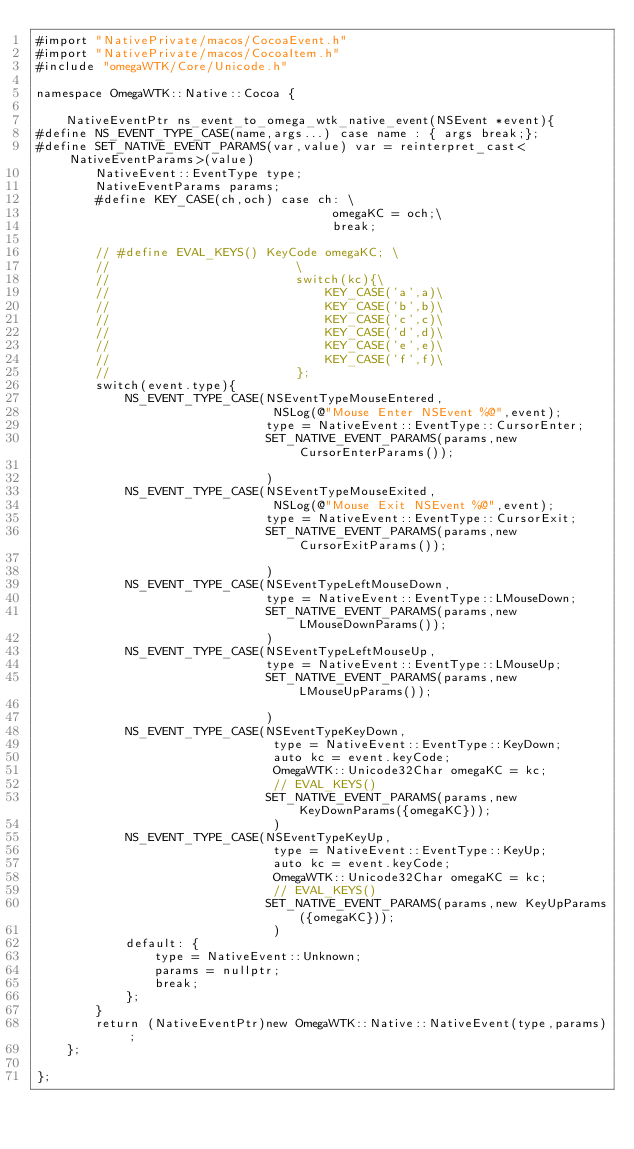Convert code to text. <code><loc_0><loc_0><loc_500><loc_500><_ObjectiveC_>#import "NativePrivate/macos/CocoaEvent.h"
#import "NativePrivate/macos/CocoaItem.h"
#include "omegaWTK/Core/Unicode.h"

namespace OmegaWTK::Native::Cocoa {

    NativeEventPtr ns_event_to_omega_wtk_native_event(NSEvent *event){
#define NS_EVENT_TYPE_CASE(name,args...) case name : { args break;};
#define SET_NATIVE_EVENT_PARAMS(var,value) var = reinterpret_cast<NativeEventParams>(value)
        NativeEvent::EventType type;
        NativeEventParams params;
        #define KEY_CASE(ch,och) case ch: \
                                        omegaKC = och;\
                                        break;

        // #define EVAL_KEYS() KeyCode omegaKC; \
        //                         \
        //                         switch(kc){\
        //                             KEY_CASE('a',a)\
        //                             KEY_CASE('b',b)\
        //                             KEY_CASE('c',c)\
        //                             KEY_CASE('d',d)\
        //                             KEY_CASE('e',e)\
        //                             KEY_CASE('f',f)\
        //                         };
        switch(event.type){
            NS_EVENT_TYPE_CASE(NSEventTypeMouseEntered,
                                NSLog(@"Mouse Enter NSEvent %@",event);
                               type = NativeEvent::EventType::CursorEnter;
                               SET_NATIVE_EVENT_PARAMS(params,new CursorEnterParams());
                               
                               )
            NS_EVENT_TYPE_CASE(NSEventTypeMouseExited,
                                NSLog(@"Mouse Exit NSEvent %@",event);
                               type = NativeEvent::EventType::CursorExit;
                               SET_NATIVE_EVENT_PARAMS(params,new CursorExitParams());
                               
                               )
            NS_EVENT_TYPE_CASE(NSEventTypeLeftMouseDown,
                               type = NativeEvent::EventType::LMouseDown;
                               SET_NATIVE_EVENT_PARAMS(params,new LMouseDownParams());
                               )
            NS_EVENT_TYPE_CASE(NSEventTypeLeftMouseUp,
                               type = NativeEvent::EventType::LMouseUp;
                               SET_NATIVE_EVENT_PARAMS(params,new LMouseUpParams());
                               
                               )
            NS_EVENT_TYPE_CASE(NSEventTypeKeyDown,
                                type = NativeEvent::EventType::KeyDown;
                                auto kc = event.keyCode;
                                OmegaWTK::Unicode32Char omegaKC = kc;
                                // EVAL_KEYS()
                               SET_NATIVE_EVENT_PARAMS(params,new KeyDownParams({omegaKC}));
                                )
            NS_EVENT_TYPE_CASE(NSEventTypeKeyUp,
                                type = NativeEvent::EventType::KeyUp;
                                auto kc = event.keyCode;
                                OmegaWTK::Unicode32Char omegaKC = kc;
                                // EVAL_KEYS()
                               SET_NATIVE_EVENT_PARAMS(params,new KeyUpParams({omegaKC}));
                                )
            default: {
                type = NativeEvent::Unknown;
                params = nullptr;
                break;
            };
        }
        return (NativeEventPtr)new OmegaWTK::Native::NativeEvent(type,params);
    };

};
</code> 